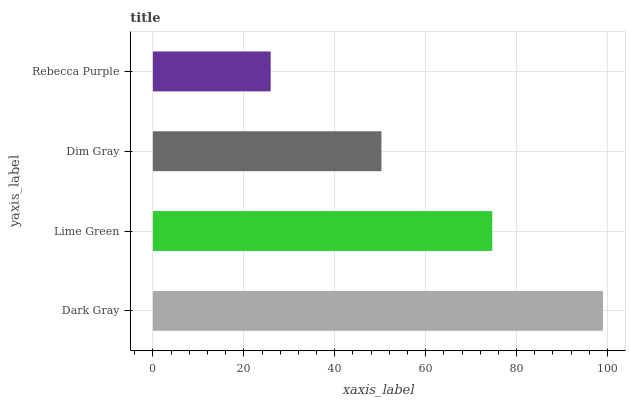Is Rebecca Purple the minimum?
Answer yes or no. Yes. Is Dark Gray the maximum?
Answer yes or no. Yes. Is Lime Green the minimum?
Answer yes or no. No. Is Lime Green the maximum?
Answer yes or no. No. Is Dark Gray greater than Lime Green?
Answer yes or no. Yes. Is Lime Green less than Dark Gray?
Answer yes or no. Yes. Is Lime Green greater than Dark Gray?
Answer yes or no. No. Is Dark Gray less than Lime Green?
Answer yes or no. No. Is Lime Green the high median?
Answer yes or no. Yes. Is Dim Gray the low median?
Answer yes or no. Yes. Is Dark Gray the high median?
Answer yes or no. No. Is Rebecca Purple the low median?
Answer yes or no. No. 